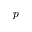Convert formula to latex. <formula><loc_0><loc_0><loc_500><loc_500>p</formula> 